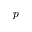Convert formula to latex. <formula><loc_0><loc_0><loc_500><loc_500>p</formula> 